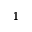Convert formula to latex. <formula><loc_0><loc_0><loc_500><loc_500>^ { 1 }</formula> 